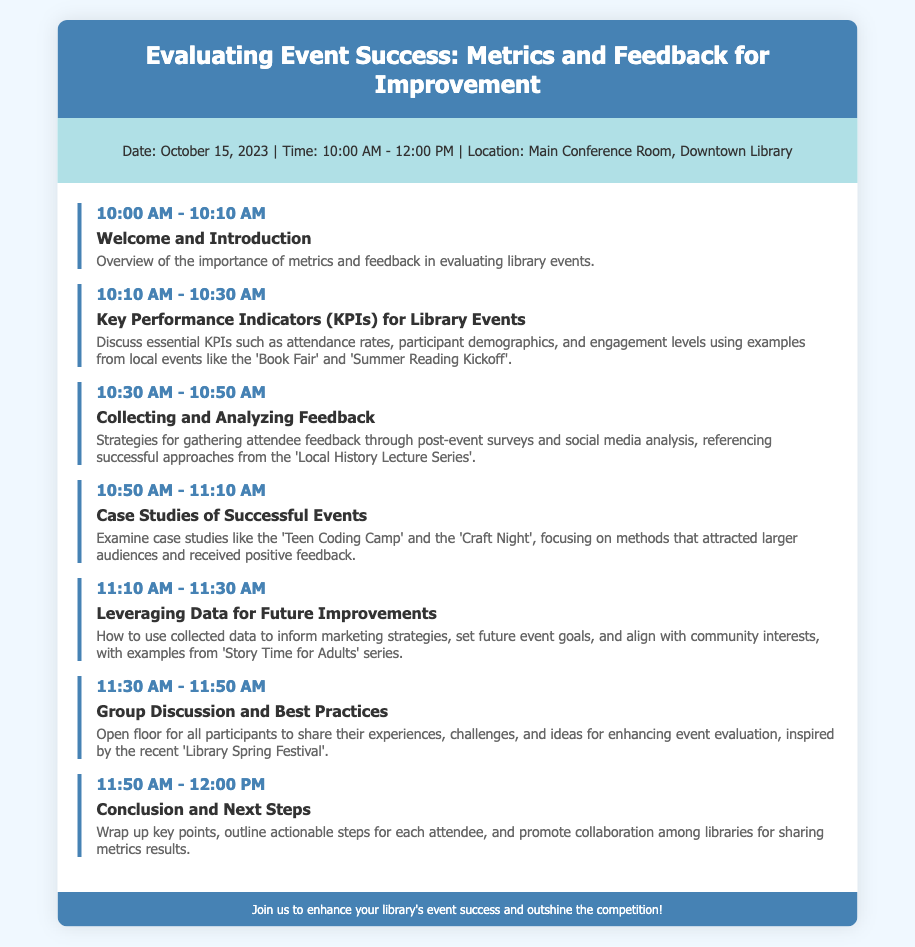What is the date of the event? The date of the event is explicitly mentioned in the document.
Answer: October 15, 2023 What time does the event start? The start time is clearly stated in the event details section.
Answer: 10:00 AM What is the location of the event? The location is specified in the event details section of the agenda.
Answer: Main Conference Room, Downtown Library Which agenda item discusses Key Performance Indicators? The title of the relevant agenda item indicates its focus on KPIs.
Answer: Key Performance Indicators (KPIs) for Library Events What case studies are mentioned in the agenda? The description of the case studies provides the names of the specific events under discussion.
Answer: Teen Coding Camp and Craft Night How long is the Group Discussion and Best Practices session? The schedule item indicates the duration of this particular session.
Answer: 20 minutes What type of data will be leveraged for future improvements? The title and description of the relevant agenda item hint at the specific data used for improvements.
Answer: Collected data What is a key takeaway from the Conclusion and Next Steps? The closing session aims to summarize key points and encourage collaborative efforts among libraries.
Answer: Promote collaboration among libraries What is the main theme of the event? The title of the document reflects the primary focus of the event.
Answer: Evaluating Event Success 